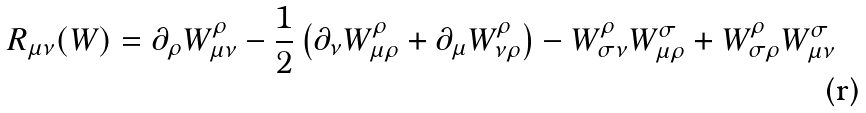<formula> <loc_0><loc_0><loc_500><loc_500>R _ { \mu \nu } ( W ) = \partial _ { \rho } W ^ { \rho } _ { \mu \nu } - \frac { 1 } { 2 } \left ( \partial _ { \nu } W ^ { \rho } _ { \mu \rho } + \partial _ { \mu } W ^ { \rho } _ { \nu \rho } \right ) - W ^ { \rho } _ { \sigma \nu } W ^ { \sigma } _ { \mu \rho } + W ^ { \rho } _ { \sigma \rho } W ^ { \sigma } _ { \mu \nu }</formula> 